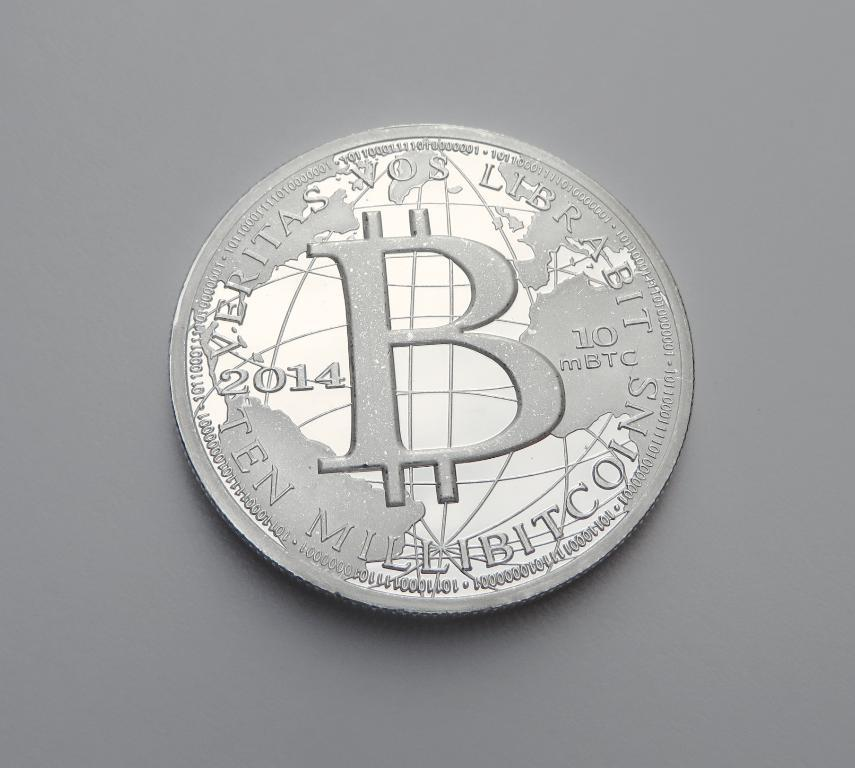<image>
Give a short and clear explanation of the subsequent image. a rendering of a ten millibitcoin with the words veritas vos librabit on the top 